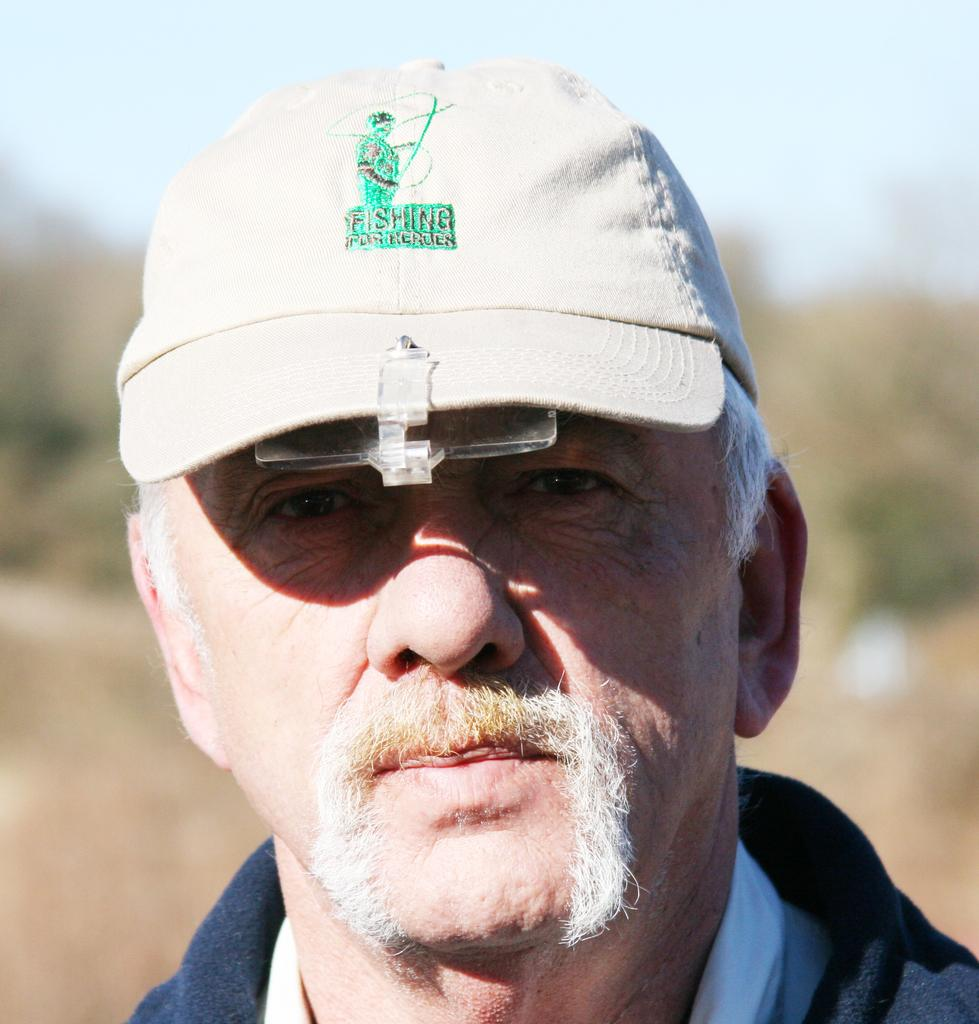Who or what is the main subject of the image? There is a person in the image. What is the person wearing on their head? The person is wearing a white cap. What can be seen in the distance behind the person? The sky is visible in the background of the image. How many ladybugs can be seen crawling on the person's elbow in the image? There are no ladybugs present in the image, and the person's elbow is not visible. 